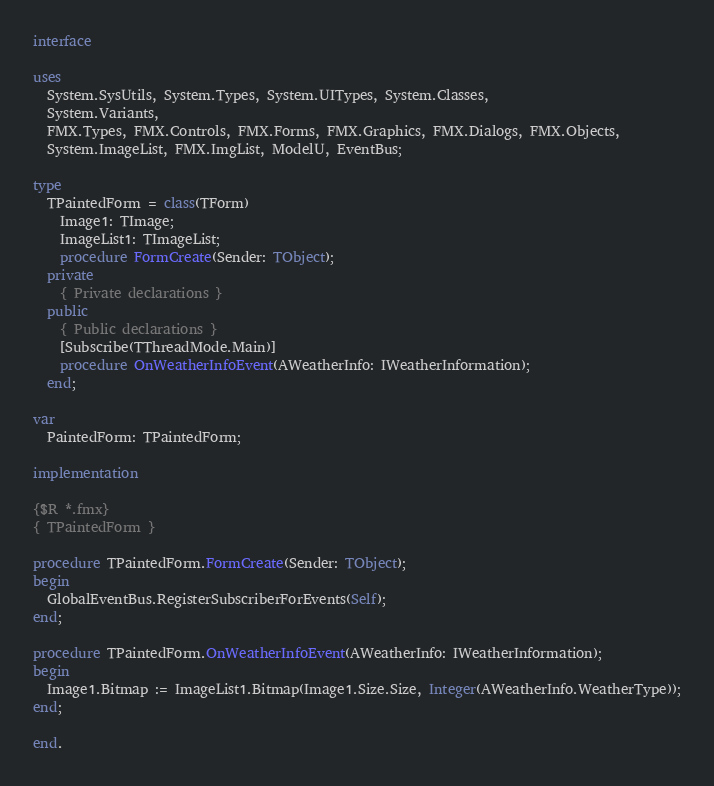<code> <loc_0><loc_0><loc_500><loc_500><_Pascal_>
interface

uses
  System.SysUtils, System.Types, System.UITypes, System.Classes,
  System.Variants,
  FMX.Types, FMX.Controls, FMX.Forms, FMX.Graphics, FMX.Dialogs, FMX.Objects,
  System.ImageList, FMX.ImgList, ModelU, EventBus;

type
  TPaintedForm = class(TForm)
    Image1: TImage;
    ImageList1: TImageList;
    procedure FormCreate(Sender: TObject);
  private
    { Private declarations }
  public
    { Public declarations }
    [Subscribe(TThreadMode.Main)]
    procedure OnWeatherInfoEvent(AWeatherInfo: IWeatherInformation);
  end;

var
  PaintedForm: TPaintedForm;

implementation

{$R *.fmx}
{ TPaintedForm }

procedure TPaintedForm.FormCreate(Sender: TObject);
begin
  GlobalEventBus.RegisterSubscriberForEvents(Self);
end;

procedure TPaintedForm.OnWeatherInfoEvent(AWeatherInfo: IWeatherInformation);
begin
  Image1.Bitmap := ImageList1.Bitmap(Image1.Size.Size, Integer(AWeatherInfo.WeatherType));
end;

end.
</code> 